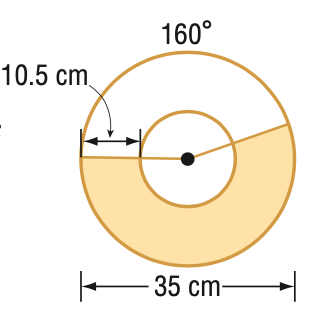Answer the mathemtical geometry problem and directly provide the correct option letter.
Question: Find the area of the shaded region. Round to the nearest tenth.
Choices: A: 85.5 B: 449.0 C: 534.5 D: 808.2 B 